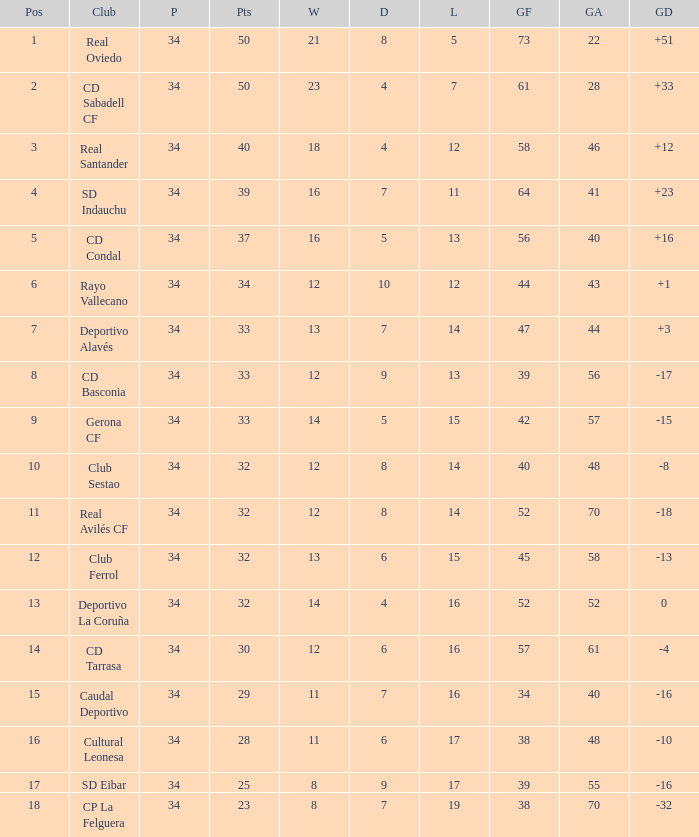How many Goals against have Played more than 34? 0.0. I'm looking to parse the entire table for insights. Could you assist me with that? {'header': ['Pos', 'Club', 'P', 'Pts', 'W', 'D', 'L', 'GF', 'GA', 'GD'], 'rows': [['1', 'Real Oviedo', '34', '50', '21', '8', '5', '73', '22', '+51'], ['2', 'CD Sabadell CF', '34', '50', '23', '4', '7', '61', '28', '+33'], ['3', 'Real Santander', '34', '40', '18', '4', '12', '58', '46', '+12'], ['4', 'SD Indauchu', '34', '39', '16', '7', '11', '64', '41', '+23'], ['5', 'CD Condal', '34', '37', '16', '5', '13', '56', '40', '+16'], ['6', 'Rayo Vallecano', '34', '34', '12', '10', '12', '44', '43', '+1'], ['7', 'Deportivo Alavés', '34', '33', '13', '7', '14', '47', '44', '+3'], ['8', 'CD Basconia', '34', '33', '12', '9', '13', '39', '56', '-17'], ['9', 'Gerona CF', '34', '33', '14', '5', '15', '42', '57', '-15'], ['10', 'Club Sestao', '34', '32', '12', '8', '14', '40', '48', '-8'], ['11', 'Real Avilés CF', '34', '32', '12', '8', '14', '52', '70', '-18'], ['12', 'Club Ferrol', '34', '32', '13', '6', '15', '45', '58', '-13'], ['13', 'Deportivo La Coruña', '34', '32', '14', '4', '16', '52', '52', '0'], ['14', 'CD Tarrasa', '34', '30', '12', '6', '16', '57', '61', '-4'], ['15', 'Caudal Deportivo', '34', '29', '11', '7', '16', '34', '40', '-16'], ['16', 'Cultural Leonesa', '34', '28', '11', '6', '17', '38', '48', '-10'], ['17', 'SD Eibar', '34', '25', '8', '9', '17', '39', '55', '-16'], ['18', 'CP La Felguera', '34', '23', '8', '7', '19', '38', '70', '-32']]} 